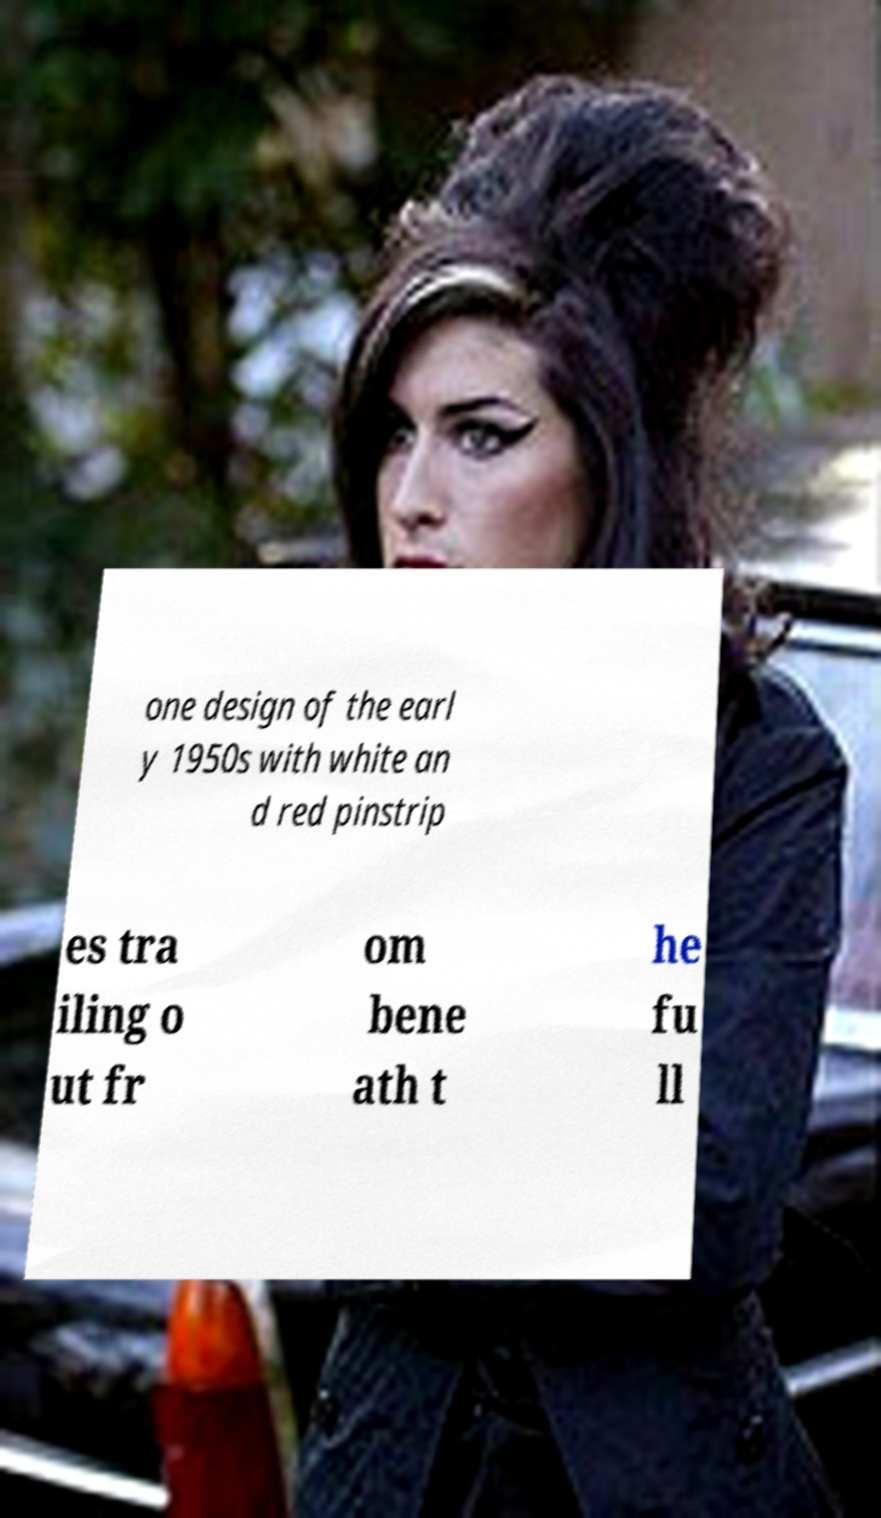Could you assist in decoding the text presented in this image and type it out clearly? one design of the earl y 1950s with white an d red pinstrip es tra iling o ut fr om bene ath t he fu ll 